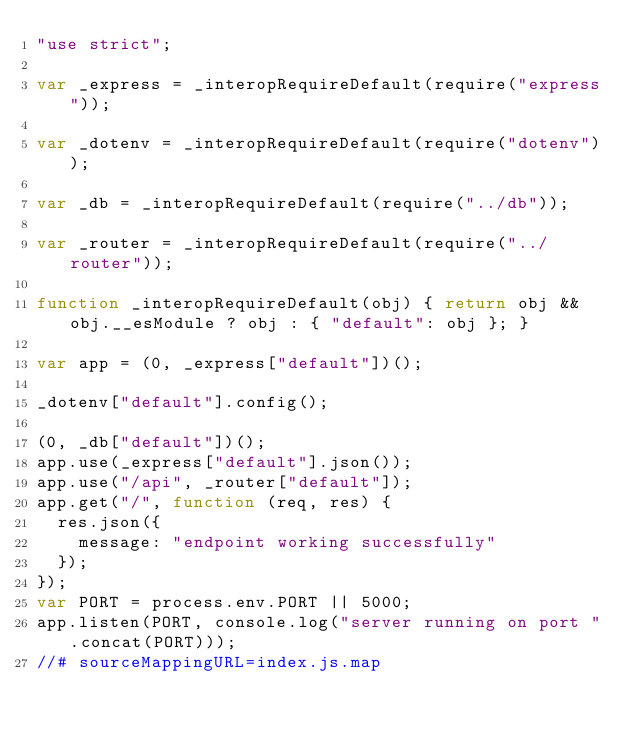Convert code to text. <code><loc_0><loc_0><loc_500><loc_500><_JavaScript_>"use strict";

var _express = _interopRequireDefault(require("express"));

var _dotenv = _interopRequireDefault(require("dotenv"));

var _db = _interopRequireDefault(require("../db"));

var _router = _interopRequireDefault(require("../router"));

function _interopRequireDefault(obj) { return obj && obj.__esModule ? obj : { "default": obj }; }

var app = (0, _express["default"])();

_dotenv["default"].config();

(0, _db["default"])();
app.use(_express["default"].json());
app.use("/api", _router["default"]);
app.get("/", function (req, res) {
  res.json({
    message: "endpoint working successfully"
  });
});
var PORT = process.env.PORT || 5000;
app.listen(PORT, console.log("server running on port ".concat(PORT)));
//# sourceMappingURL=index.js.map</code> 